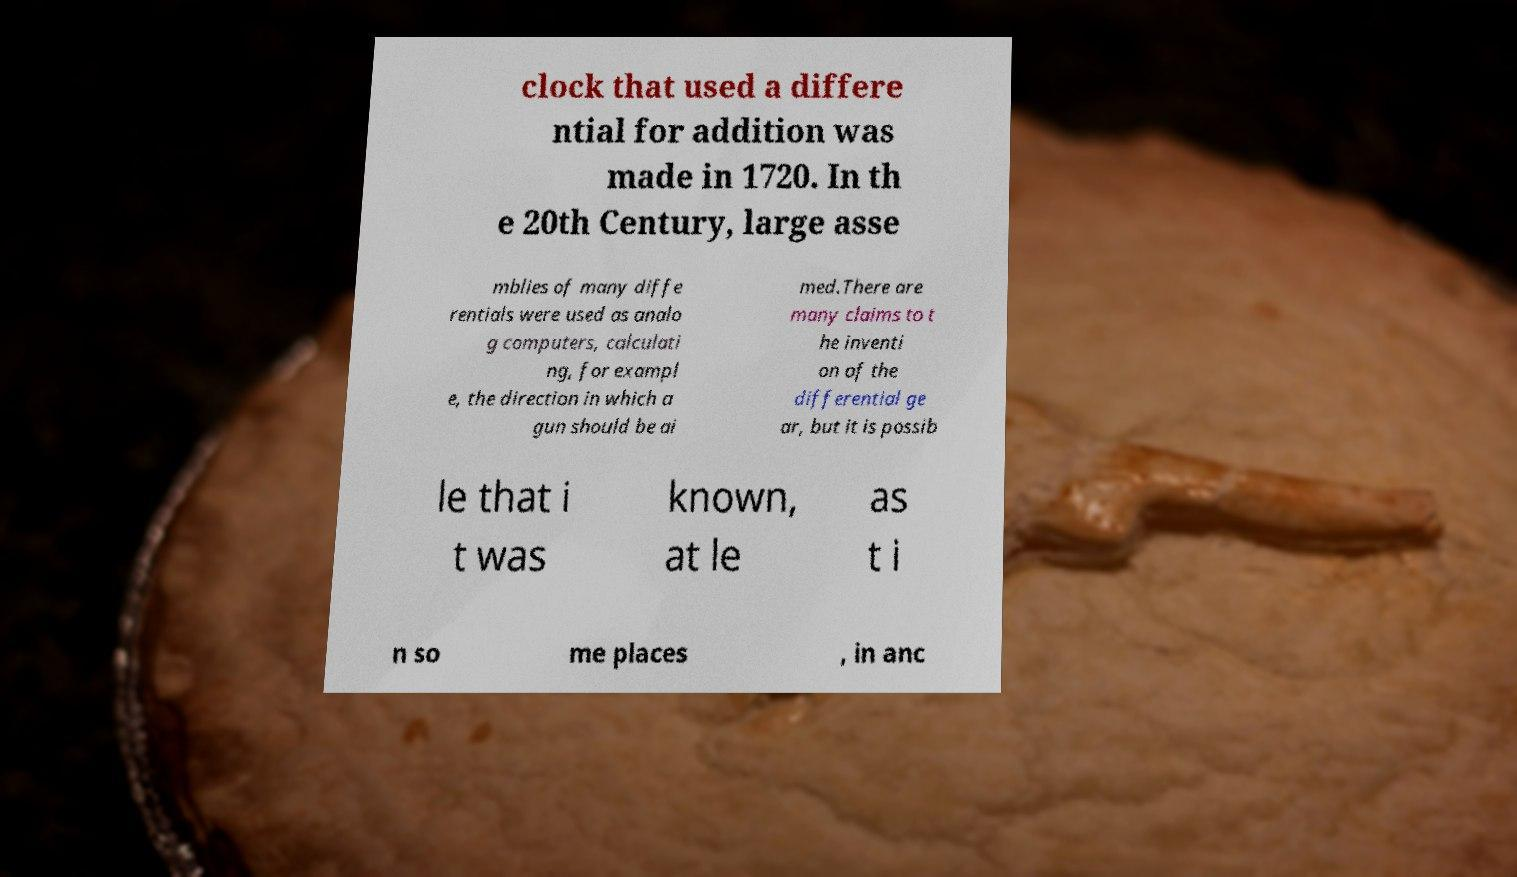Could you extract and type out the text from this image? clock that used a differe ntial for addition was made in 1720. In th e 20th Century, large asse mblies of many diffe rentials were used as analo g computers, calculati ng, for exampl e, the direction in which a gun should be ai med.There are many claims to t he inventi on of the differential ge ar, but it is possib le that i t was known, at le as t i n so me places , in anc 